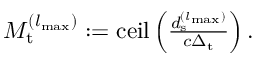<formula> <loc_0><loc_0><loc_500><loc_500>\begin{array} { r } { M _ { t } ^ { ( { l _ { \max } } ) } \colon = c e i l \left ( \frac { d _ { s } ^ { ( { l _ { \max } } ) } } { c \Delta _ { t } } \right ) . } \end{array}</formula> 